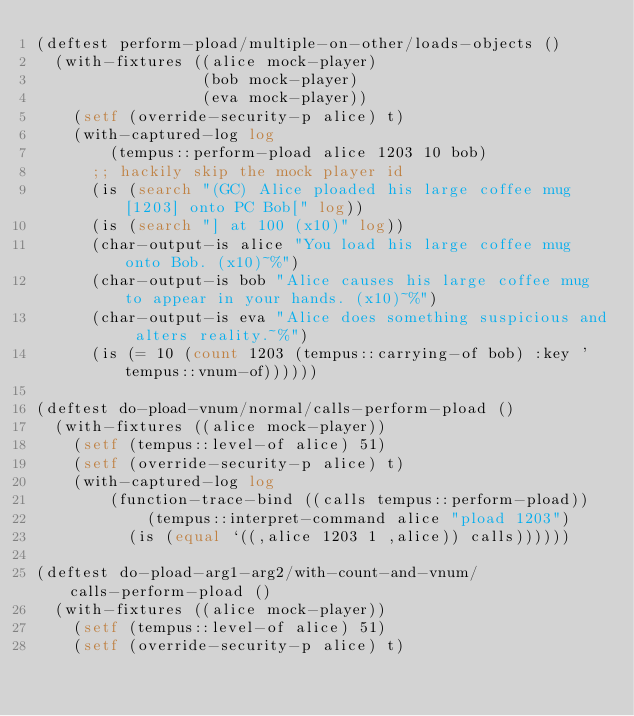Convert code to text. <code><loc_0><loc_0><loc_500><loc_500><_Lisp_>(deftest perform-pload/multiple-on-other/loads-objects ()
  (with-fixtures ((alice mock-player)
                  (bob mock-player)
                  (eva mock-player))
    (setf (override-security-p alice) t)
    (with-captured-log log
        (tempus::perform-pload alice 1203 10 bob)
      ;; hackily skip the mock player id
      (is (search "(GC) Alice ploaded his large coffee mug[1203] onto PC Bob[" log))
      (is (search "] at 100 (x10)" log))
      (char-output-is alice "You load his large coffee mug onto Bob. (x10)~%")
      (char-output-is bob "Alice causes his large coffee mug to appear in your hands. (x10)~%")
      (char-output-is eva "Alice does something suspicious and alters reality.~%")
      (is (= 10 (count 1203 (tempus::carrying-of bob) :key 'tempus::vnum-of))))))

(deftest do-pload-vnum/normal/calls-perform-pload ()
  (with-fixtures ((alice mock-player))
    (setf (tempus::level-of alice) 51)
    (setf (override-security-p alice) t)
    (with-captured-log log
        (function-trace-bind ((calls tempus::perform-pload))
            (tempus::interpret-command alice "pload 1203")
          (is (equal `((,alice 1203 1 ,alice)) calls))))))

(deftest do-pload-arg1-arg2/with-count-and-vnum/calls-perform-pload ()
  (with-fixtures ((alice mock-player))
    (setf (tempus::level-of alice) 51)
    (setf (override-security-p alice) t)</code> 